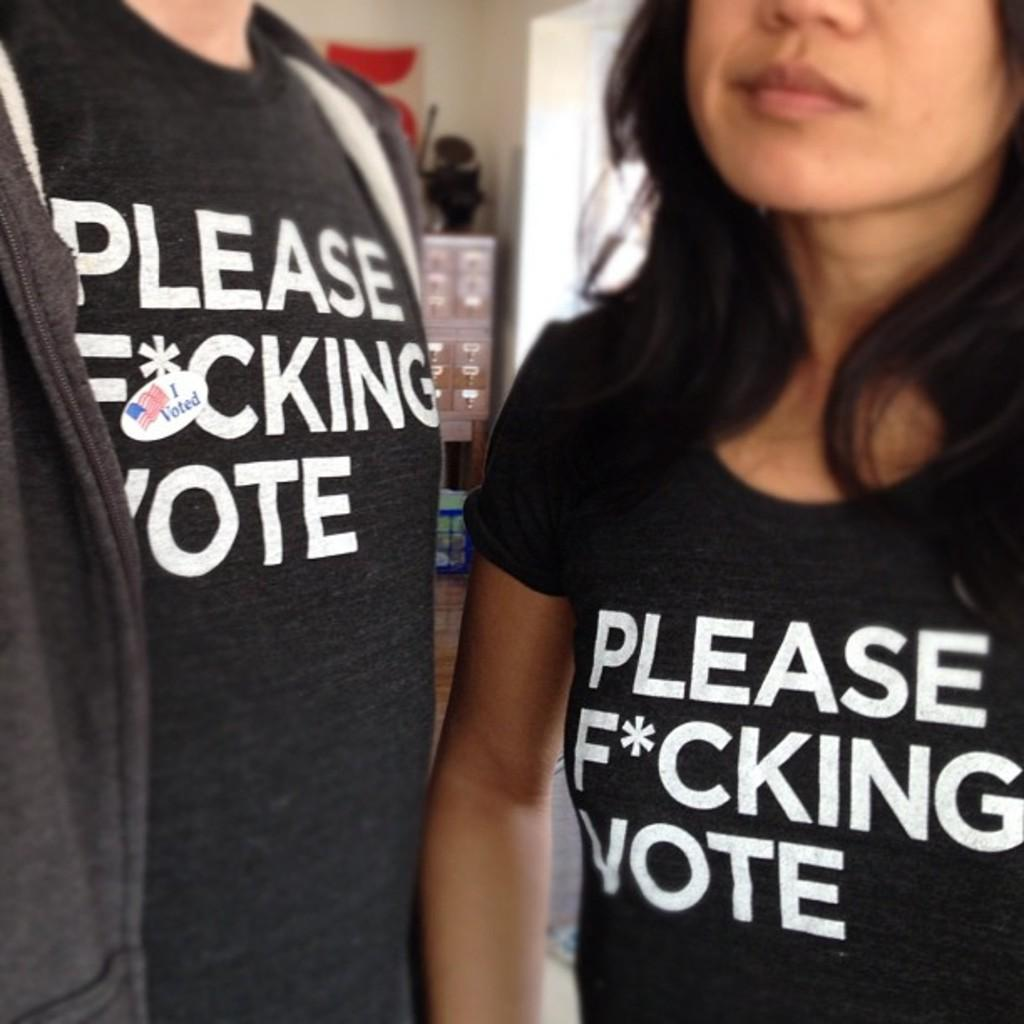<image>
Provide a brief description of the given image. People are wearing funny black shirts to encourage voting. 